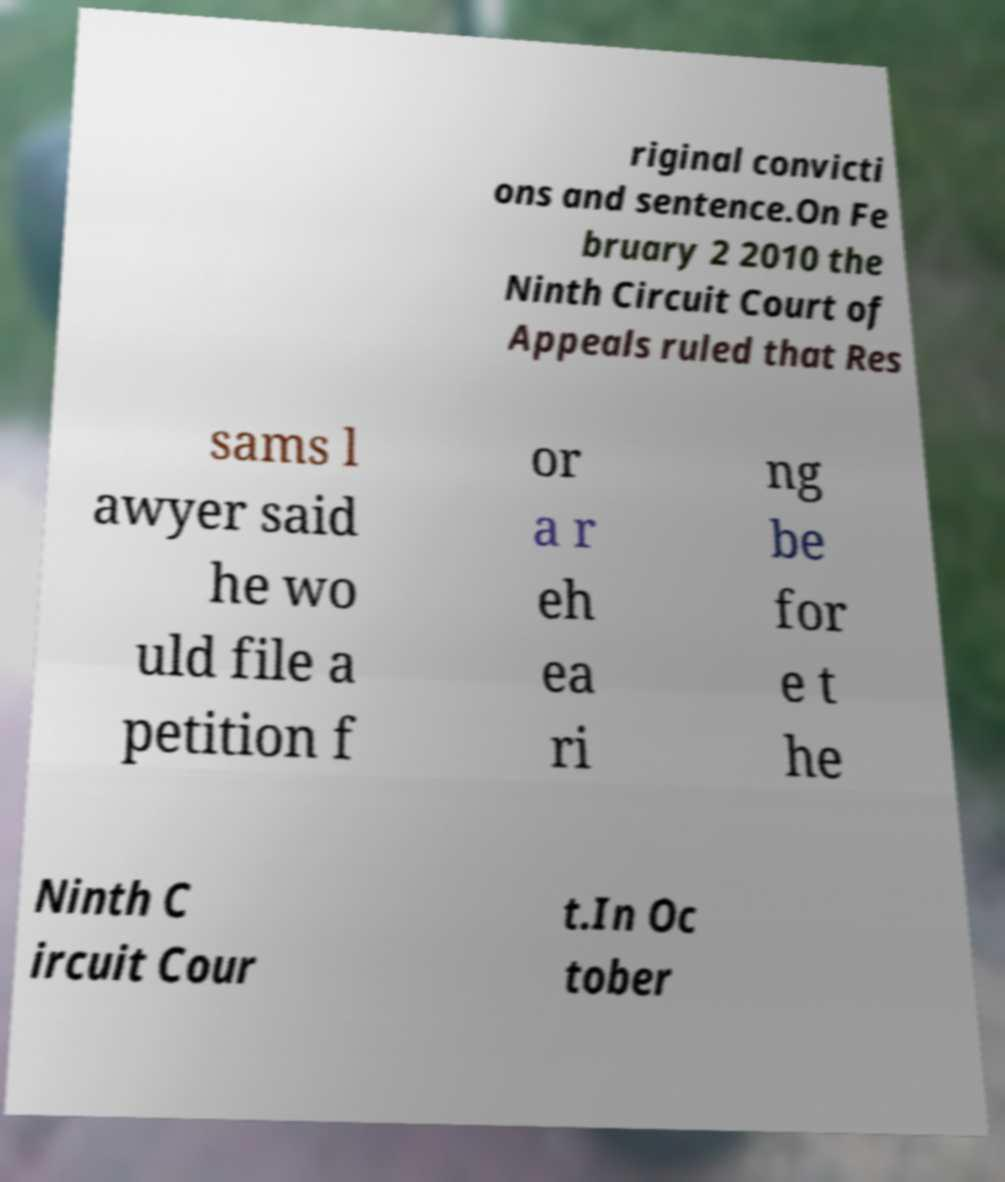Can you read and provide the text displayed in the image?This photo seems to have some interesting text. Can you extract and type it out for me? riginal convicti ons and sentence.On Fe bruary 2 2010 the Ninth Circuit Court of Appeals ruled that Res sams l awyer said he wo uld file a petition f or a r eh ea ri ng be for e t he Ninth C ircuit Cour t.In Oc tober 